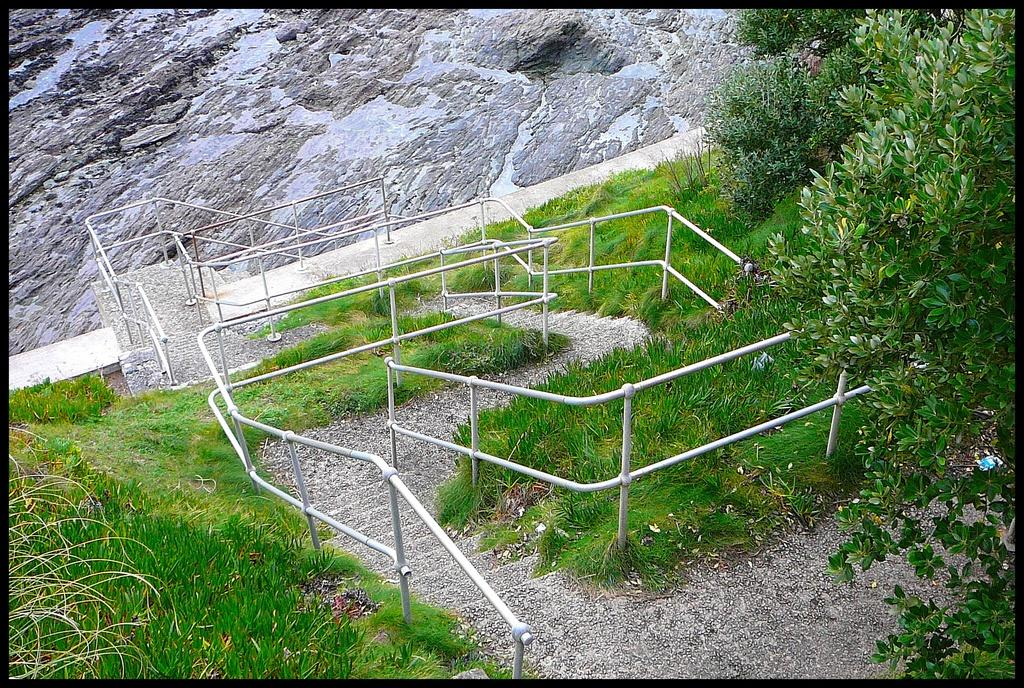What type of structure is visible in the image? There are steps in the image. What is the surrounding area like around the steps? There is a lot of grass around the steps. What can be seen on the right side of the image? There are trees on the right side of the image. What is the surface behind the steps made of? There is a rock surface behind the steps. What type of advice is given by the rock surface in the image? There is no advice given by the rock surface in the image; it is a stationary surface behind the steps. 